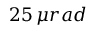<formula> <loc_0><loc_0><loc_500><loc_500>2 5 \, \mu r a d</formula> 